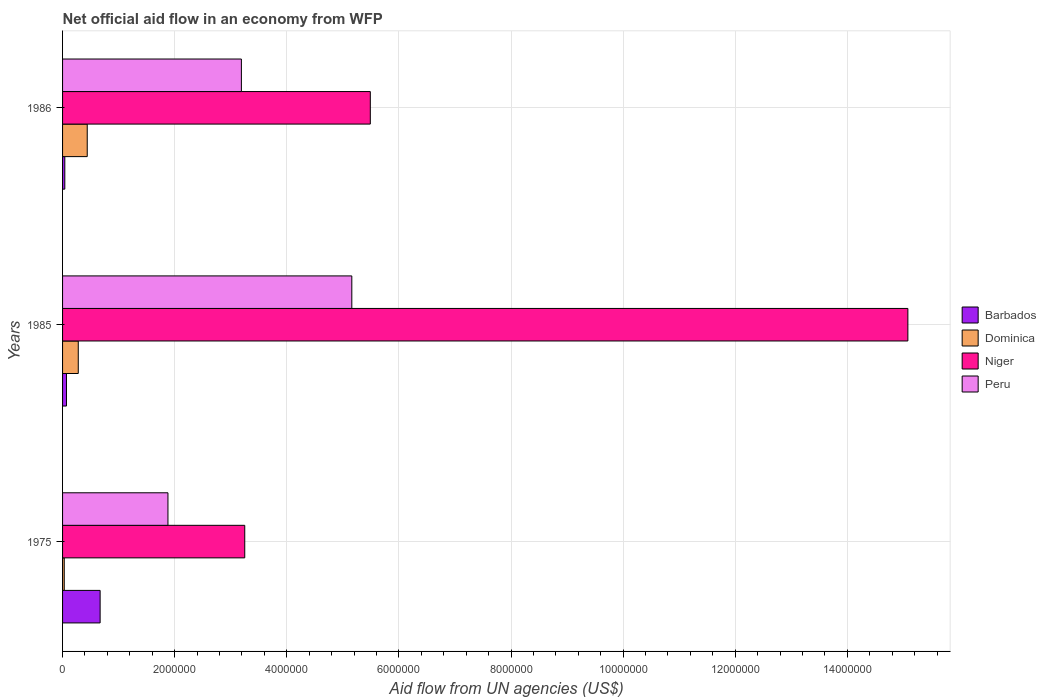Are the number of bars per tick equal to the number of legend labels?
Provide a short and direct response. Yes. In how many cases, is the number of bars for a given year not equal to the number of legend labels?
Your answer should be very brief. 0. In which year was the net official aid flow in Peru minimum?
Your answer should be compact. 1975. What is the total net official aid flow in Dominica in the graph?
Offer a very short reply. 7.50e+05. What is the difference between the net official aid flow in Barbados in 1975 and that in 1986?
Offer a very short reply. 6.30e+05. What is the difference between the net official aid flow in Peru in 1985 and the net official aid flow in Dominica in 1986?
Give a very brief answer. 4.72e+06. What is the average net official aid flow in Niger per year?
Offer a terse response. 7.94e+06. In the year 1985, what is the difference between the net official aid flow in Niger and net official aid flow in Dominica?
Provide a short and direct response. 1.48e+07. What is the ratio of the net official aid flow in Barbados in 1985 to that in 1986?
Offer a terse response. 1.75. Is the net official aid flow in Barbados in 1985 less than that in 1986?
Your response must be concise. No. Is the difference between the net official aid flow in Niger in 1985 and 1986 greater than the difference between the net official aid flow in Dominica in 1985 and 1986?
Offer a very short reply. Yes. In how many years, is the net official aid flow in Peru greater than the average net official aid flow in Peru taken over all years?
Give a very brief answer. 1. Is it the case that in every year, the sum of the net official aid flow in Dominica and net official aid flow in Barbados is greater than the sum of net official aid flow in Peru and net official aid flow in Niger?
Your response must be concise. No. What does the 4th bar from the top in 1975 represents?
Provide a short and direct response. Barbados. Is it the case that in every year, the sum of the net official aid flow in Barbados and net official aid flow in Dominica is greater than the net official aid flow in Peru?
Your response must be concise. No. Are all the bars in the graph horizontal?
Offer a terse response. Yes. How many years are there in the graph?
Your response must be concise. 3. What is the difference between two consecutive major ticks on the X-axis?
Provide a succinct answer. 2.00e+06. Are the values on the major ticks of X-axis written in scientific E-notation?
Offer a very short reply. No. Does the graph contain any zero values?
Your answer should be compact. No. How many legend labels are there?
Offer a terse response. 4. How are the legend labels stacked?
Your response must be concise. Vertical. What is the title of the graph?
Offer a very short reply. Net official aid flow in an economy from WFP. What is the label or title of the X-axis?
Your answer should be compact. Aid flow from UN agencies (US$). What is the Aid flow from UN agencies (US$) of Barbados in 1975?
Your answer should be compact. 6.70e+05. What is the Aid flow from UN agencies (US$) of Niger in 1975?
Make the answer very short. 3.25e+06. What is the Aid flow from UN agencies (US$) of Peru in 1975?
Your answer should be very brief. 1.88e+06. What is the Aid flow from UN agencies (US$) in Dominica in 1985?
Provide a succinct answer. 2.80e+05. What is the Aid flow from UN agencies (US$) in Niger in 1985?
Make the answer very short. 1.51e+07. What is the Aid flow from UN agencies (US$) in Peru in 1985?
Offer a very short reply. 5.16e+06. What is the Aid flow from UN agencies (US$) in Niger in 1986?
Your answer should be very brief. 5.49e+06. What is the Aid flow from UN agencies (US$) in Peru in 1986?
Provide a succinct answer. 3.19e+06. Across all years, what is the maximum Aid flow from UN agencies (US$) of Barbados?
Provide a succinct answer. 6.70e+05. Across all years, what is the maximum Aid flow from UN agencies (US$) of Niger?
Give a very brief answer. 1.51e+07. Across all years, what is the maximum Aid flow from UN agencies (US$) in Peru?
Give a very brief answer. 5.16e+06. Across all years, what is the minimum Aid flow from UN agencies (US$) in Barbados?
Offer a very short reply. 4.00e+04. Across all years, what is the minimum Aid flow from UN agencies (US$) in Niger?
Provide a short and direct response. 3.25e+06. Across all years, what is the minimum Aid flow from UN agencies (US$) in Peru?
Ensure brevity in your answer.  1.88e+06. What is the total Aid flow from UN agencies (US$) in Barbados in the graph?
Your answer should be very brief. 7.80e+05. What is the total Aid flow from UN agencies (US$) of Dominica in the graph?
Provide a succinct answer. 7.50e+05. What is the total Aid flow from UN agencies (US$) in Niger in the graph?
Your answer should be compact. 2.38e+07. What is the total Aid flow from UN agencies (US$) in Peru in the graph?
Give a very brief answer. 1.02e+07. What is the difference between the Aid flow from UN agencies (US$) of Niger in 1975 and that in 1985?
Offer a very short reply. -1.18e+07. What is the difference between the Aid flow from UN agencies (US$) in Peru in 1975 and that in 1985?
Provide a short and direct response. -3.28e+06. What is the difference between the Aid flow from UN agencies (US$) in Barbados in 1975 and that in 1986?
Offer a very short reply. 6.30e+05. What is the difference between the Aid flow from UN agencies (US$) of Dominica in 1975 and that in 1986?
Your response must be concise. -4.10e+05. What is the difference between the Aid flow from UN agencies (US$) of Niger in 1975 and that in 1986?
Your answer should be very brief. -2.24e+06. What is the difference between the Aid flow from UN agencies (US$) in Peru in 1975 and that in 1986?
Ensure brevity in your answer.  -1.31e+06. What is the difference between the Aid flow from UN agencies (US$) in Barbados in 1985 and that in 1986?
Your answer should be compact. 3.00e+04. What is the difference between the Aid flow from UN agencies (US$) of Niger in 1985 and that in 1986?
Your response must be concise. 9.59e+06. What is the difference between the Aid flow from UN agencies (US$) in Peru in 1985 and that in 1986?
Your response must be concise. 1.97e+06. What is the difference between the Aid flow from UN agencies (US$) of Barbados in 1975 and the Aid flow from UN agencies (US$) of Dominica in 1985?
Provide a short and direct response. 3.90e+05. What is the difference between the Aid flow from UN agencies (US$) in Barbados in 1975 and the Aid flow from UN agencies (US$) in Niger in 1985?
Make the answer very short. -1.44e+07. What is the difference between the Aid flow from UN agencies (US$) in Barbados in 1975 and the Aid flow from UN agencies (US$) in Peru in 1985?
Your answer should be very brief. -4.49e+06. What is the difference between the Aid flow from UN agencies (US$) of Dominica in 1975 and the Aid flow from UN agencies (US$) of Niger in 1985?
Your response must be concise. -1.50e+07. What is the difference between the Aid flow from UN agencies (US$) in Dominica in 1975 and the Aid flow from UN agencies (US$) in Peru in 1985?
Keep it short and to the point. -5.13e+06. What is the difference between the Aid flow from UN agencies (US$) in Niger in 1975 and the Aid flow from UN agencies (US$) in Peru in 1985?
Give a very brief answer. -1.91e+06. What is the difference between the Aid flow from UN agencies (US$) of Barbados in 1975 and the Aid flow from UN agencies (US$) of Dominica in 1986?
Your answer should be very brief. 2.30e+05. What is the difference between the Aid flow from UN agencies (US$) in Barbados in 1975 and the Aid flow from UN agencies (US$) in Niger in 1986?
Offer a very short reply. -4.82e+06. What is the difference between the Aid flow from UN agencies (US$) of Barbados in 1975 and the Aid flow from UN agencies (US$) of Peru in 1986?
Your answer should be compact. -2.52e+06. What is the difference between the Aid flow from UN agencies (US$) of Dominica in 1975 and the Aid flow from UN agencies (US$) of Niger in 1986?
Make the answer very short. -5.46e+06. What is the difference between the Aid flow from UN agencies (US$) in Dominica in 1975 and the Aid flow from UN agencies (US$) in Peru in 1986?
Offer a terse response. -3.16e+06. What is the difference between the Aid flow from UN agencies (US$) in Niger in 1975 and the Aid flow from UN agencies (US$) in Peru in 1986?
Give a very brief answer. 6.00e+04. What is the difference between the Aid flow from UN agencies (US$) of Barbados in 1985 and the Aid flow from UN agencies (US$) of Dominica in 1986?
Offer a very short reply. -3.70e+05. What is the difference between the Aid flow from UN agencies (US$) in Barbados in 1985 and the Aid flow from UN agencies (US$) in Niger in 1986?
Offer a terse response. -5.42e+06. What is the difference between the Aid flow from UN agencies (US$) in Barbados in 1985 and the Aid flow from UN agencies (US$) in Peru in 1986?
Your answer should be compact. -3.12e+06. What is the difference between the Aid flow from UN agencies (US$) in Dominica in 1985 and the Aid flow from UN agencies (US$) in Niger in 1986?
Ensure brevity in your answer.  -5.21e+06. What is the difference between the Aid flow from UN agencies (US$) of Dominica in 1985 and the Aid flow from UN agencies (US$) of Peru in 1986?
Your response must be concise. -2.91e+06. What is the difference between the Aid flow from UN agencies (US$) of Niger in 1985 and the Aid flow from UN agencies (US$) of Peru in 1986?
Provide a short and direct response. 1.19e+07. What is the average Aid flow from UN agencies (US$) in Barbados per year?
Your answer should be very brief. 2.60e+05. What is the average Aid flow from UN agencies (US$) in Dominica per year?
Provide a succinct answer. 2.50e+05. What is the average Aid flow from UN agencies (US$) in Niger per year?
Ensure brevity in your answer.  7.94e+06. What is the average Aid flow from UN agencies (US$) of Peru per year?
Your response must be concise. 3.41e+06. In the year 1975, what is the difference between the Aid flow from UN agencies (US$) in Barbados and Aid flow from UN agencies (US$) in Dominica?
Offer a very short reply. 6.40e+05. In the year 1975, what is the difference between the Aid flow from UN agencies (US$) in Barbados and Aid flow from UN agencies (US$) in Niger?
Provide a succinct answer. -2.58e+06. In the year 1975, what is the difference between the Aid flow from UN agencies (US$) in Barbados and Aid flow from UN agencies (US$) in Peru?
Your answer should be very brief. -1.21e+06. In the year 1975, what is the difference between the Aid flow from UN agencies (US$) in Dominica and Aid flow from UN agencies (US$) in Niger?
Make the answer very short. -3.22e+06. In the year 1975, what is the difference between the Aid flow from UN agencies (US$) in Dominica and Aid flow from UN agencies (US$) in Peru?
Your answer should be very brief. -1.85e+06. In the year 1975, what is the difference between the Aid flow from UN agencies (US$) of Niger and Aid flow from UN agencies (US$) of Peru?
Offer a terse response. 1.37e+06. In the year 1985, what is the difference between the Aid flow from UN agencies (US$) of Barbados and Aid flow from UN agencies (US$) of Niger?
Offer a terse response. -1.50e+07. In the year 1985, what is the difference between the Aid flow from UN agencies (US$) of Barbados and Aid flow from UN agencies (US$) of Peru?
Keep it short and to the point. -5.09e+06. In the year 1985, what is the difference between the Aid flow from UN agencies (US$) in Dominica and Aid flow from UN agencies (US$) in Niger?
Provide a short and direct response. -1.48e+07. In the year 1985, what is the difference between the Aid flow from UN agencies (US$) of Dominica and Aid flow from UN agencies (US$) of Peru?
Offer a very short reply. -4.88e+06. In the year 1985, what is the difference between the Aid flow from UN agencies (US$) in Niger and Aid flow from UN agencies (US$) in Peru?
Your answer should be compact. 9.92e+06. In the year 1986, what is the difference between the Aid flow from UN agencies (US$) of Barbados and Aid flow from UN agencies (US$) of Dominica?
Offer a very short reply. -4.00e+05. In the year 1986, what is the difference between the Aid flow from UN agencies (US$) of Barbados and Aid flow from UN agencies (US$) of Niger?
Your response must be concise. -5.45e+06. In the year 1986, what is the difference between the Aid flow from UN agencies (US$) of Barbados and Aid flow from UN agencies (US$) of Peru?
Make the answer very short. -3.15e+06. In the year 1986, what is the difference between the Aid flow from UN agencies (US$) of Dominica and Aid flow from UN agencies (US$) of Niger?
Give a very brief answer. -5.05e+06. In the year 1986, what is the difference between the Aid flow from UN agencies (US$) of Dominica and Aid flow from UN agencies (US$) of Peru?
Your response must be concise. -2.75e+06. In the year 1986, what is the difference between the Aid flow from UN agencies (US$) in Niger and Aid flow from UN agencies (US$) in Peru?
Make the answer very short. 2.30e+06. What is the ratio of the Aid flow from UN agencies (US$) of Barbados in 1975 to that in 1985?
Keep it short and to the point. 9.57. What is the ratio of the Aid flow from UN agencies (US$) in Dominica in 1975 to that in 1985?
Give a very brief answer. 0.11. What is the ratio of the Aid flow from UN agencies (US$) in Niger in 1975 to that in 1985?
Your answer should be very brief. 0.22. What is the ratio of the Aid flow from UN agencies (US$) of Peru in 1975 to that in 1985?
Keep it short and to the point. 0.36. What is the ratio of the Aid flow from UN agencies (US$) in Barbados in 1975 to that in 1986?
Provide a succinct answer. 16.75. What is the ratio of the Aid flow from UN agencies (US$) in Dominica in 1975 to that in 1986?
Keep it short and to the point. 0.07. What is the ratio of the Aid flow from UN agencies (US$) of Niger in 1975 to that in 1986?
Your response must be concise. 0.59. What is the ratio of the Aid flow from UN agencies (US$) of Peru in 1975 to that in 1986?
Your answer should be very brief. 0.59. What is the ratio of the Aid flow from UN agencies (US$) of Dominica in 1985 to that in 1986?
Offer a terse response. 0.64. What is the ratio of the Aid flow from UN agencies (US$) of Niger in 1985 to that in 1986?
Make the answer very short. 2.75. What is the ratio of the Aid flow from UN agencies (US$) of Peru in 1985 to that in 1986?
Offer a very short reply. 1.62. What is the difference between the highest and the second highest Aid flow from UN agencies (US$) of Niger?
Your answer should be compact. 9.59e+06. What is the difference between the highest and the second highest Aid flow from UN agencies (US$) of Peru?
Your answer should be very brief. 1.97e+06. What is the difference between the highest and the lowest Aid flow from UN agencies (US$) in Barbados?
Ensure brevity in your answer.  6.30e+05. What is the difference between the highest and the lowest Aid flow from UN agencies (US$) of Niger?
Make the answer very short. 1.18e+07. What is the difference between the highest and the lowest Aid flow from UN agencies (US$) of Peru?
Your answer should be compact. 3.28e+06. 